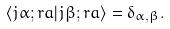<formula> <loc_0><loc_0><loc_500><loc_500>\langle j \alpha ; r a | j \beta ; r a \rangle = \delta _ { \alpha , \beta } .</formula> 